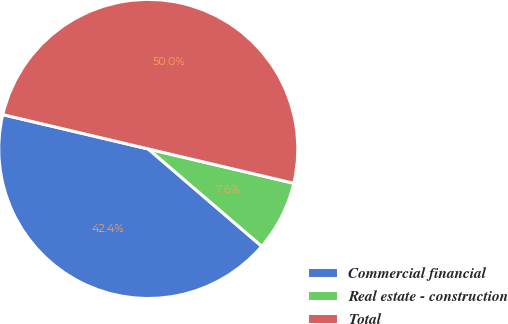<chart> <loc_0><loc_0><loc_500><loc_500><pie_chart><fcel>Commercial financial<fcel>Real estate - construction<fcel>Total<nl><fcel>42.4%<fcel>7.6%<fcel>50.0%<nl></chart> 